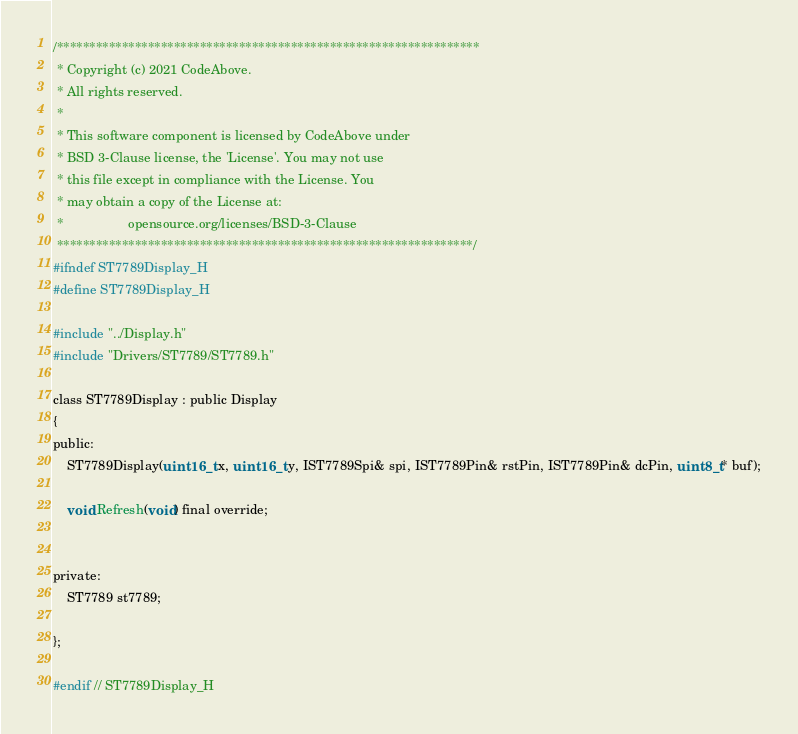Convert code to text. <code><loc_0><loc_0><loc_500><loc_500><_C_>/*****************************************************************
 * Copyright (c) 2021 CodeAbove.
 * All rights reserved.
 *
 * This software component is licensed by CodeAbove under
 * BSD 3-Clause license, the 'License'. You may not use
 * this file except in compliance with the License. You
 * may obtain a copy of the License at:
 *                  opensource.org/licenses/BSD-3-Clause
 ****************************************************************/
#ifndef ST7789Display_H
#define ST7789Display_H

#include "../Display.h"
#include "Drivers/ST7789/ST7789.h"

class ST7789Display : public Display
{
public:
    ST7789Display(uint16_t x, uint16_t y, IST7789Spi& spi, IST7789Pin& rstPin, IST7789Pin& dcPin, uint8_t* buf);
    
    void Refresh(void) final override;


private:
    ST7789 st7789;

};

#endif // ST7789Display_H</code> 